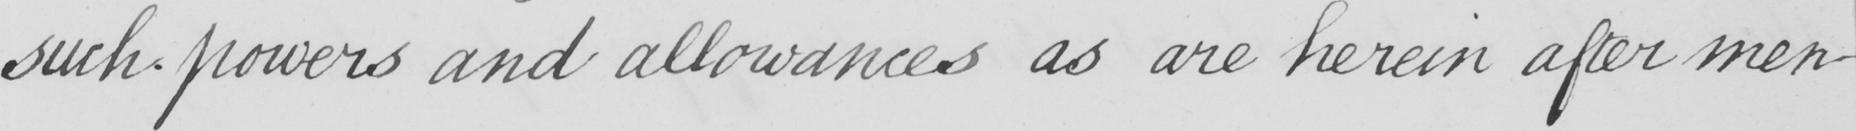Please transcribe the handwritten text in this image. such powers and allowances as are herein after men- 